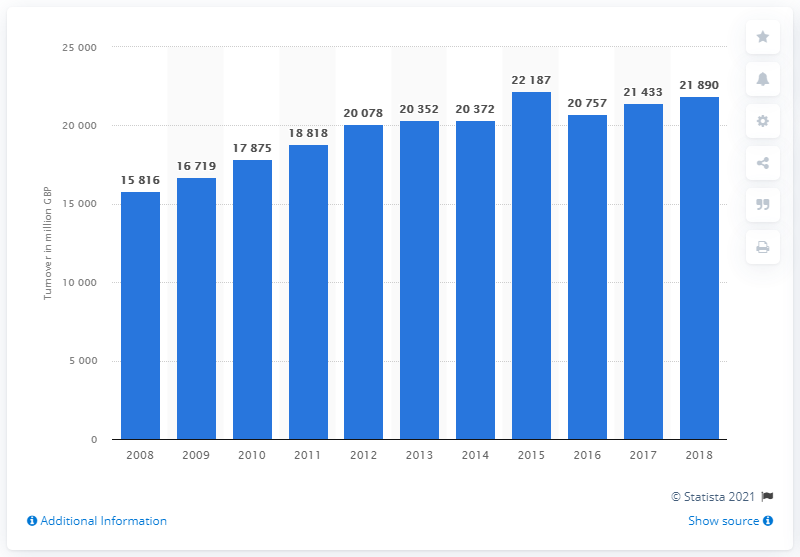Give some essential details in this illustration. In 2018, the turnover of bakery products was 21,890. 